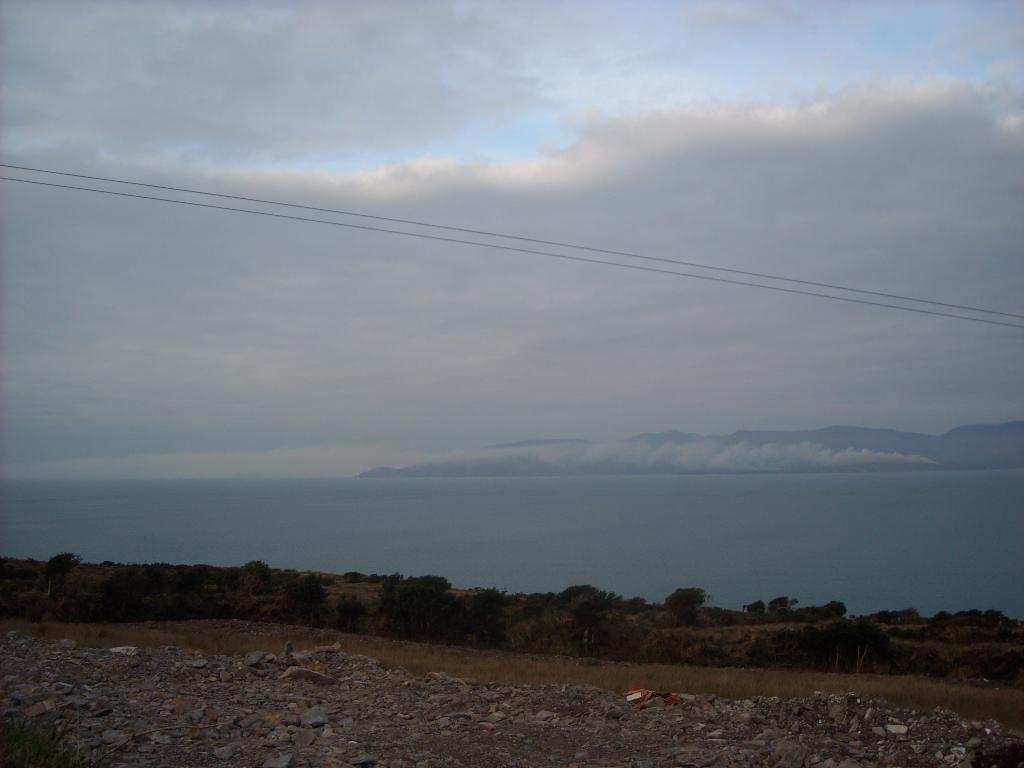How would you summarize this image in a sentence or two? At the bottom of the image, we can see stones, few objects, trees and plants. Background we can see the water, hills and cloudy sky. Here we can see the wires in the image. 